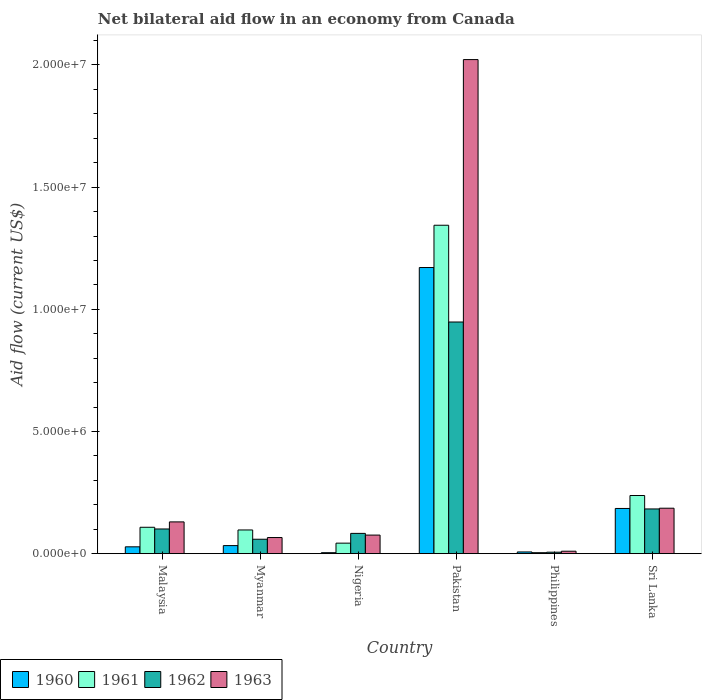How many different coloured bars are there?
Ensure brevity in your answer.  4. How many groups of bars are there?
Offer a very short reply. 6. Are the number of bars per tick equal to the number of legend labels?
Provide a succinct answer. Yes. What is the label of the 2nd group of bars from the left?
Ensure brevity in your answer.  Myanmar. In how many cases, is the number of bars for a given country not equal to the number of legend labels?
Your response must be concise. 0. What is the net bilateral aid flow in 1961 in Sri Lanka?
Offer a terse response. 2.38e+06. Across all countries, what is the maximum net bilateral aid flow in 1963?
Offer a terse response. 2.02e+07. In which country was the net bilateral aid flow in 1963 maximum?
Keep it short and to the point. Pakistan. What is the total net bilateral aid flow in 1960 in the graph?
Offer a very short reply. 1.43e+07. What is the difference between the net bilateral aid flow in 1963 in Myanmar and that in Sri Lanka?
Give a very brief answer. -1.20e+06. What is the difference between the net bilateral aid flow in 1962 in Pakistan and the net bilateral aid flow in 1963 in Sri Lanka?
Offer a terse response. 7.62e+06. What is the average net bilateral aid flow in 1960 per country?
Give a very brief answer. 2.38e+06. What is the ratio of the net bilateral aid flow in 1961 in Pakistan to that in Sri Lanka?
Make the answer very short. 5.65. What is the difference between the highest and the second highest net bilateral aid flow in 1961?
Offer a very short reply. 1.11e+07. What is the difference between the highest and the lowest net bilateral aid flow in 1963?
Give a very brief answer. 2.01e+07. Is the sum of the net bilateral aid flow in 1960 in Malaysia and Pakistan greater than the maximum net bilateral aid flow in 1961 across all countries?
Provide a succinct answer. No. Is it the case that in every country, the sum of the net bilateral aid flow in 1960 and net bilateral aid flow in 1961 is greater than the sum of net bilateral aid flow in 1963 and net bilateral aid flow in 1962?
Offer a very short reply. No. What does the 4th bar from the left in Nigeria represents?
Make the answer very short. 1963. Is it the case that in every country, the sum of the net bilateral aid flow in 1960 and net bilateral aid flow in 1962 is greater than the net bilateral aid flow in 1961?
Offer a terse response. No. Are all the bars in the graph horizontal?
Provide a short and direct response. No. How many countries are there in the graph?
Keep it short and to the point. 6. Does the graph contain grids?
Keep it short and to the point. No. Where does the legend appear in the graph?
Keep it short and to the point. Bottom left. How are the legend labels stacked?
Give a very brief answer. Horizontal. What is the title of the graph?
Your answer should be compact. Net bilateral aid flow in an economy from Canada. Does "2006" appear as one of the legend labels in the graph?
Give a very brief answer. No. What is the label or title of the Y-axis?
Offer a terse response. Aid flow (current US$). What is the Aid flow (current US$) in 1960 in Malaysia?
Keep it short and to the point. 2.80e+05. What is the Aid flow (current US$) in 1961 in Malaysia?
Make the answer very short. 1.08e+06. What is the Aid flow (current US$) in 1962 in Malaysia?
Ensure brevity in your answer.  1.01e+06. What is the Aid flow (current US$) in 1963 in Malaysia?
Your answer should be compact. 1.30e+06. What is the Aid flow (current US$) of 1961 in Myanmar?
Offer a terse response. 9.70e+05. What is the Aid flow (current US$) in 1962 in Myanmar?
Your answer should be compact. 5.90e+05. What is the Aid flow (current US$) of 1960 in Nigeria?
Ensure brevity in your answer.  4.00e+04. What is the Aid flow (current US$) in 1961 in Nigeria?
Ensure brevity in your answer.  4.30e+05. What is the Aid flow (current US$) in 1962 in Nigeria?
Your response must be concise. 8.30e+05. What is the Aid flow (current US$) of 1963 in Nigeria?
Offer a terse response. 7.60e+05. What is the Aid flow (current US$) of 1960 in Pakistan?
Make the answer very short. 1.17e+07. What is the Aid flow (current US$) of 1961 in Pakistan?
Your response must be concise. 1.34e+07. What is the Aid flow (current US$) of 1962 in Pakistan?
Offer a very short reply. 9.48e+06. What is the Aid flow (current US$) of 1963 in Pakistan?
Your answer should be compact. 2.02e+07. What is the Aid flow (current US$) in 1961 in Philippines?
Make the answer very short. 4.00e+04. What is the Aid flow (current US$) of 1960 in Sri Lanka?
Your answer should be very brief. 1.85e+06. What is the Aid flow (current US$) of 1961 in Sri Lanka?
Make the answer very short. 2.38e+06. What is the Aid flow (current US$) in 1962 in Sri Lanka?
Your answer should be compact. 1.83e+06. What is the Aid flow (current US$) in 1963 in Sri Lanka?
Your answer should be very brief. 1.86e+06. Across all countries, what is the maximum Aid flow (current US$) in 1960?
Provide a succinct answer. 1.17e+07. Across all countries, what is the maximum Aid flow (current US$) of 1961?
Give a very brief answer. 1.34e+07. Across all countries, what is the maximum Aid flow (current US$) in 1962?
Offer a terse response. 9.48e+06. Across all countries, what is the maximum Aid flow (current US$) in 1963?
Give a very brief answer. 2.02e+07. Across all countries, what is the minimum Aid flow (current US$) in 1961?
Ensure brevity in your answer.  4.00e+04. Across all countries, what is the minimum Aid flow (current US$) in 1962?
Your response must be concise. 6.00e+04. Across all countries, what is the minimum Aid flow (current US$) in 1963?
Make the answer very short. 1.00e+05. What is the total Aid flow (current US$) of 1960 in the graph?
Provide a short and direct response. 1.43e+07. What is the total Aid flow (current US$) of 1961 in the graph?
Keep it short and to the point. 1.83e+07. What is the total Aid flow (current US$) in 1962 in the graph?
Keep it short and to the point. 1.38e+07. What is the total Aid flow (current US$) of 1963 in the graph?
Provide a short and direct response. 2.49e+07. What is the difference between the Aid flow (current US$) of 1960 in Malaysia and that in Myanmar?
Ensure brevity in your answer.  -5.00e+04. What is the difference between the Aid flow (current US$) of 1961 in Malaysia and that in Myanmar?
Your answer should be very brief. 1.10e+05. What is the difference between the Aid flow (current US$) in 1962 in Malaysia and that in Myanmar?
Ensure brevity in your answer.  4.20e+05. What is the difference between the Aid flow (current US$) of 1963 in Malaysia and that in Myanmar?
Give a very brief answer. 6.40e+05. What is the difference between the Aid flow (current US$) of 1960 in Malaysia and that in Nigeria?
Your answer should be compact. 2.40e+05. What is the difference between the Aid flow (current US$) of 1961 in Malaysia and that in Nigeria?
Ensure brevity in your answer.  6.50e+05. What is the difference between the Aid flow (current US$) in 1963 in Malaysia and that in Nigeria?
Provide a succinct answer. 5.40e+05. What is the difference between the Aid flow (current US$) of 1960 in Malaysia and that in Pakistan?
Ensure brevity in your answer.  -1.14e+07. What is the difference between the Aid flow (current US$) in 1961 in Malaysia and that in Pakistan?
Your response must be concise. -1.24e+07. What is the difference between the Aid flow (current US$) in 1962 in Malaysia and that in Pakistan?
Provide a succinct answer. -8.47e+06. What is the difference between the Aid flow (current US$) of 1963 in Malaysia and that in Pakistan?
Ensure brevity in your answer.  -1.89e+07. What is the difference between the Aid flow (current US$) in 1960 in Malaysia and that in Philippines?
Ensure brevity in your answer.  2.10e+05. What is the difference between the Aid flow (current US$) of 1961 in Malaysia and that in Philippines?
Your answer should be very brief. 1.04e+06. What is the difference between the Aid flow (current US$) of 1962 in Malaysia and that in Philippines?
Ensure brevity in your answer.  9.50e+05. What is the difference between the Aid flow (current US$) of 1963 in Malaysia and that in Philippines?
Keep it short and to the point. 1.20e+06. What is the difference between the Aid flow (current US$) in 1960 in Malaysia and that in Sri Lanka?
Ensure brevity in your answer.  -1.57e+06. What is the difference between the Aid flow (current US$) of 1961 in Malaysia and that in Sri Lanka?
Provide a short and direct response. -1.30e+06. What is the difference between the Aid flow (current US$) of 1962 in Malaysia and that in Sri Lanka?
Make the answer very short. -8.20e+05. What is the difference between the Aid flow (current US$) in 1963 in Malaysia and that in Sri Lanka?
Your answer should be compact. -5.60e+05. What is the difference between the Aid flow (current US$) in 1961 in Myanmar and that in Nigeria?
Ensure brevity in your answer.  5.40e+05. What is the difference between the Aid flow (current US$) in 1962 in Myanmar and that in Nigeria?
Offer a terse response. -2.40e+05. What is the difference between the Aid flow (current US$) of 1960 in Myanmar and that in Pakistan?
Provide a short and direct response. -1.14e+07. What is the difference between the Aid flow (current US$) of 1961 in Myanmar and that in Pakistan?
Offer a terse response. -1.25e+07. What is the difference between the Aid flow (current US$) in 1962 in Myanmar and that in Pakistan?
Keep it short and to the point. -8.89e+06. What is the difference between the Aid flow (current US$) in 1963 in Myanmar and that in Pakistan?
Your answer should be compact. -1.96e+07. What is the difference between the Aid flow (current US$) of 1960 in Myanmar and that in Philippines?
Ensure brevity in your answer.  2.60e+05. What is the difference between the Aid flow (current US$) in 1961 in Myanmar and that in Philippines?
Provide a short and direct response. 9.30e+05. What is the difference between the Aid flow (current US$) of 1962 in Myanmar and that in Philippines?
Keep it short and to the point. 5.30e+05. What is the difference between the Aid flow (current US$) in 1963 in Myanmar and that in Philippines?
Offer a terse response. 5.60e+05. What is the difference between the Aid flow (current US$) in 1960 in Myanmar and that in Sri Lanka?
Offer a terse response. -1.52e+06. What is the difference between the Aid flow (current US$) in 1961 in Myanmar and that in Sri Lanka?
Your answer should be compact. -1.41e+06. What is the difference between the Aid flow (current US$) in 1962 in Myanmar and that in Sri Lanka?
Provide a succinct answer. -1.24e+06. What is the difference between the Aid flow (current US$) in 1963 in Myanmar and that in Sri Lanka?
Ensure brevity in your answer.  -1.20e+06. What is the difference between the Aid flow (current US$) of 1960 in Nigeria and that in Pakistan?
Provide a short and direct response. -1.17e+07. What is the difference between the Aid flow (current US$) of 1961 in Nigeria and that in Pakistan?
Your answer should be very brief. -1.30e+07. What is the difference between the Aid flow (current US$) in 1962 in Nigeria and that in Pakistan?
Ensure brevity in your answer.  -8.65e+06. What is the difference between the Aid flow (current US$) in 1963 in Nigeria and that in Pakistan?
Provide a succinct answer. -1.95e+07. What is the difference between the Aid flow (current US$) in 1960 in Nigeria and that in Philippines?
Make the answer very short. -3.00e+04. What is the difference between the Aid flow (current US$) in 1962 in Nigeria and that in Philippines?
Give a very brief answer. 7.70e+05. What is the difference between the Aid flow (current US$) of 1960 in Nigeria and that in Sri Lanka?
Keep it short and to the point. -1.81e+06. What is the difference between the Aid flow (current US$) in 1961 in Nigeria and that in Sri Lanka?
Provide a short and direct response. -1.95e+06. What is the difference between the Aid flow (current US$) in 1962 in Nigeria and that in Sri Lanka?
Ensure brevity in your answer.  -1.00e+06. What is the difference between the Aid flow (current US$) in 1963 in Nigeria and that in Sri Lanka?
Offer a terse response. -1.10e+06. What is the difference between the Aid flow (current US$) of 1960 in Pakistan and that in Philippines?
Provide a short and direct response. 1.16e+07. What is the difference between the Aid flow (current US$) in 1961 in Pakistan and that in Philippines?
Your answer should be very brief. 1.34e+07. What is the difference between the Aid flow (current US$) of 1962 in Pakistan and that in Philippines?
Your answer should be compact. 9.42e+06. What is the difference between the Aid flow (current US$) of 1963 in Pakistan and that in Philippines?
Offer a terse response. 2.01e+07. What is the difference between the Aid flow (current US$) of 1960 in Pakistan and that in Sri Lanka?
Offer a terse response. 9.86e+06. What is the difference between the Aid flow (current US$) in 1961 in Pakistan and that in Sri Lanka?
Give a very brief answer. 1.11e+07. What is the difference between the Aid flow (current US$) in 1962 in Pakistan and that in Sri Lanka?
Your answer should be very brief. 7.65e+06. What is the difference between the Aid flow (current US$) in 1963 in Pakistan and that in Sri Lanka?
Offer a terse response. 1.84e+07. What is the difference between the Aid flow (current US$) of 1960 in Philippines and that in Sri Lanka?
Make the answer very short. -1.78e+06. What is the difference between the Aid flow (current US$) in 1961 in Philippines and that in Sri Lanka?
Offer a terse response. -2.34e+06. What is the difference between the Aid flow (current US$) of 1962 in Philippines and that in Sri Lanka?
Your answer should be very brief. -1.77e+06. What is the difference between the Aid flow (current US$) of 1963 in Philippines and that in Sri Lanka?
Keep it short and to the point. -1.76e+06. What is the difference between the Aid flow (current US$) in 1960 in Malaysia and the Aid flow (current US$) in 1961 in Myanmar?
Your response must be concise. -6.90e+05. What is the difference between the Aid flow (current US$) of 1960 in Malaysia and the Aid flow (current US$) of 1962 in Myanmar?
Your response must be concise. -3.10e+05. What is the difference between the Aid flow (current US$) in 1960 in Malaysia and the Aid flow (current US$) in 1963 in Myanmar?
Your response must be concise. -3.80e+05. What is the difference between the Aid flow (current US$) in 1960 in Malaysia and the Aid flow (current US$) in 1962 in Nigeria?
Ensure brevity in your answer.  -5.50e+05. What is the difference between the Aid flow (current US$) of 1960 in Malaysia and the Aid flow (current US$) of 1963 in Nigeria?
Keep it short and to the point. -4.80e+05. What is the difference between the Aid flow (current US$) of 1961 in Malaysia and the Aid flow (current US$) of 1962 in Nigeria?
Give a very brief answer. 2.50e+05. What is the difference between the Aid flow (current US$) of 1961 in Malaysia and the Aid flow (current US$) of 1963 in Nigeria?
Give a very brief answer. 3.20e+05. What is the difference between the Aid flow (current US$) of 1960 in Malaysia and the Aid flow (current US$) of 1961 in Pakistan?
Give a very brief answer. -1.32e+07. What is the difference between the Aid flow (current US$) of 1960 in Malaysia and the Aid flow (current US$) of 1962 in Pakistan?
Provide a short and direct response. -9.20e+06. What is the difference between the Aid flow (current US$) in 1960 in Malaysia and the Aid flow (current US$) in 1963 in Pakistan?
Offer a very short reply. -1.99e+07. What is the difference between the Aid flow (current US$) of 1961 in Malaysia and the Aid flow (current US$) of 1962 in Pakistan?
Offer a terse response. -8.40e+06. What is the difference between the Aid flow (current US$) in 1961 in Malaysia and the Aid flow (current US$) in 1963 in Pakistan?
Ensure brevity in your answer.  -1.91e+07. What is the difference between the Aid flow (current US$) in 1962 in Malaysia and the Aid flow (current US$) in 1963 in Pakistan?
Provide a short and direct response. -1.92e+07. What is the difference between the Aid flow (current US$) of 1961 in Malaysia and the Aid flow (current US$) of 1962 in Philippines?
Provide a short and direct response. 1.02e+06. What is the difference between the Aid flow (current US$) of 1961 in Malaysia and the Aid flow (current US$) of 1963 in Philippines?
Give a very brief answer. 9.80e+05. What is the difference between the Aid flow (current US$) of 1962 in Malaysia and the Aid flow (current US$) of 1963 in Philippines?
Your answer should be very brief. 9.10e+05. What is the difference between the Aid flow (current US$) in 1960 in Malaysia and the Aid flow (current US$) in 1961 in Sri Lanka?
Give a very brief answer. -2.10e+06. What is the difference between the Aid flow (current US$) of 1960 in Malaysia and the Aid flow (current US$) of 1962 in Sri Lanka?
Provide a short and direct response. -1.55e+06. What is the difference between the Aid flow (current US$) of 1960 in Malaysia and the Aid flow (current US$) of 1963 in Sri Lanka?
Provide a short and direct response. -1.58e+06. What is the difference between the Aid flow (current US$) in 1961 in Malaysia and the Aid flow (current US$) in 1962 in Sri Lanka?
Your answer should be very brief. -7.50e+05. What is the difference between the Aid flow (current US$) in 1961 in Malaysia and the Aid flow (current US$) in 1963 in Sri Lanka?
Your response must be concise. -7.80e+05. What is the difference between the Aid flow (current US$) of 1962 in Malaysia and the Aid flow (current US$) of 1963 in Sri Lanka?
Your answer should be very brief. -8.50e+05. What is the difference between the Aid flow (current US$) of 1960 in Myanmar and the Aid flow (current US$) of 1962 in Nigeria?
Provide a succinct answer. -5.00e+05. What is the difference between the Aid flow (current US$) in 1960 in Myanmar and the Aid flow (current US$) in 1963 in Nigeria?
Your response must be concise. -4.30e+05. What is the difference between the Aid flow (current US$) of 1961 in Myanmar and the Aid flow (current US$) of 1962 in Nigeria?
Provide a short and direct response. 1.40e+05. What is the difference between the Aid flow (current US$) of 1960 in Myanmar and the Aid flow (current US$) of 1961 in Pakistan?
Give a very brief answer. -1.31e+07. What is the difference between the Aid flow (current US$) in 1960 in Myanmar and the Aid flow (current US$) in 1962 in Pakistan?
Provide a short and direct response. -9.15e+06. What is the difference between the Aid flow (current US$) of 1960 in Myanmar and the Aid flow (current US$) of 1963 in Pakistan?
Offer a terse response. -1.99e+07. What is the difference between the Aid flow (current US$) of 1961 in Myanmar and the Aid flow (current US$) of 1962 in Pakistan?
Your answer should be very brief. -8.51e+06. What is the difference between the Aid flow (current US$) of 1961 in Myanmar and the Aid flow (current US$) of 1963 in Pakistan?
Your answer should be very brief. -1.92e+07. What is the difference between the Aid flow (current US$) of 1962 in Myanmar and the Aid flow (current US$) of 1963 in Pakistan?
Offer a terse response. -1.96e+07. What is the difference between the Aid flow (current US$) of 1960 in Myanmar and the Aid flow (current US$) of 1962 in Philippines?
Provide a succinct answer. 2.70e+05. What is the difference between the Aid flow (current US$) in 1961 in Myanmar and the Aid flow (current US$) in 1962 in Philippines?
Provide a short and direct response. 9.10e+05. What is the difference between the Aid flow (current US$) of 1961 in Myanmar and the Aid flow (current US$) of 1963 in Philippines?
Offer a very short reply. 8.70e+05. What is the difference between the Aid flow (current US$) of 1960 in Myanmar and the Aid flow (current US$) of 1961 in Sri Lanka?
Make the answer very short. -2.05e+06. What is the difference between the Aid flow (current US$) in 1960 in Myanmar and the Aid flow (current US$) in 1962 in Sri Lanka?
Your answer should be very brief. -1.50e+06. What is the difference between the Aid flow (current US$) of 1960 in Myanmar and the Aid flow (current US$) of 1963 in Sri Lanka?
Keep it short and to the point. -1.53e+06. What is the difference between the Aid flow (current US$) in 1961 in Myanmar and the Aid flow (current US$) in 1962 in Sri Lanka?
Keep it short and to the point. -8.60e+05. What is the difference between the Aid flow (current US$) in 1961 in Myanmar and the Aid flow (current US$) in 1963 in Sri Lanka?
Make the answer very short. -8.90e+05. What is the difference between the Aid flow (current US$) in 1962 in Myanmar and the Aid flow (current US$) in 1963 in Sri Lanka?
Offer a terse response. -1.27e+06. What is the difference between the Aid flow (current US$) in 1960 in Nigeria and the Aid flow (current US$) in 1961 in Pakistan?
Provide a succinct answer. -1.34e+07. What is the difference between the Aid flow (current US$) of 1960 in Nigeria and the Aid flow (current US$) of 1962 in Pakistan?
Make the answer very short. -9.44e+06. What is the difference between the Aid flow (current US$) of 1960 in Nigeria and the Aid flow (current US$) of 1963 in Pakistan?
Keep it short and to the point. -2.02e+07. What is the difference between the Aid flow (current US$) in 1961 in Nigeria and the Aid flow (current US$) in 1962 in Pakistan?
Your answer should be compact. -9.05e+06. What is the difference between the Aid flow (current US$) of 1961 in Nigeria and the Aid flow (current US$) of 1963 in Pakistan?
Your answer should be very brief. -1.98e+07. What is the difference between the Aid flow (current US$) of 1962 in Nigeria and the Aid flow (current US$) of 1963 in Pakistan?
Give a very brief answer. -1.94e+07. What is the difference between the Aid flow (current US$) of 1960 in Nigeria and the Aid flow (current US$) of 1961 in Philippines?
Provide a succinct answer. 0. What is the difference between the Aid flow (current US$) in 1960 in Nigeria and the Aid flow (current US$) in 1962 in Philippines?
Offer a terse response. -2.00e+04. What is the difference between the Aid flow (current US$) of 1960 in Nigeria and the Aid flow (current US$) of 1963 in Philippines?
Your answer should be compact. -6.00e+04. What is the difference between the Aid flow (current US$) of 1961 in Nigeria and the Aid flow (current US$) of 1963 in Philippines?
Give a very brief answer. 3.30e+05. What is the difference between the Aid flow (current US$) in 1962 in Nigeria and the Aid flow (current US$) in 1963 in Philippines?
Offer a terse response. 7.30e+05. What is the difference between the Aid flow (current US$) of 1960 in Nigeria and the Aid flow (current US$) of 1961 in Sri Lanka?
Ensure brevity in your answer.  -2.34e+06. What is the difference between the Aid flow (current US$) in 1960 in Nigeria and the Aid flow (current US$) in 1962 in Sri Lanka?
Your answer should be very brief. -1.79e+06. What is the difference between the Aid flow (current US$) of 1960 in Nigeria and the Aid flow (current US$) of 1963 in Sri Lanka?
Offer a very short reply. -1.82e+06. What is the difference between the Aid flow (current US$) of 1961 in Nigeria and the Aid flow (current US$) of 1962 in Sri Lanka?
Offer a terse response. -1.40e+06. What is the difference between the Aid flow (current US$) in 1961 in Nigeria and the Aid flow (current US$) in 1963 in Sri Lanka?
Give a very brief answer. -1.43e+06. What is the difference between the Aid flow (current US$) of 1962 in Nigeria and the Aid flow (current US$) of 1963 in Sri Lanka?
Your answer should be compact. -1.03e+06. What is the difference between the Aid flow (current US$) of 1960 in Pakistan and the Aid flow (current US$) of 1961 in Philippines?
Provide a short and direct response. 1.17e+07. What is the difference between the Aid flow (current US$) of 1960 in Pakistan and the Aid flow (current US$) of 1962 in Philippines?
Make the answer very short. 1.16e+07. What is the difference between the Aid flow (current US$) in 1960 in Pakistan and the Aid flow (current US$) in 1963 in Philippines?
Your response must be concise. 1.16e+07. What is the difference between the Aid flow (current US$) in 1961 in Pakistan and the Aid flow (current US$) in 1962 in Philippines?
Keep it short and to the point. 1.34e+07. What is the difference between the Aid flow (current US$) in 1961 in Pakistan and the Aid flow (current US$) in 1963 in Philippines?
Provide a succinct answer. 1.33e+07. What is the difference between the Aid flow (current US$) of 1962 in Pakistan and the Aid flow (current US$) of 1963 in Philippines?
Give a very brief answer. 9.38e+06. What is the difference between the Aid flow (current US$) in 1960 in Pakistan and the Aid flow (current US$) in 1961 in Sri Lanka?
Give a very brief answer. 9.33e+06. What is the difference between the Aid flow (current US$) in 1960 in Pakistan and the Aid flow (current US$) in 1962 in Sri Lanka?
Make the answer very short. 9.88e+06. What is the difference between the Aid flow (current US$) of 1960 in Pakistan and the Aid flow (current US$) of 1963 in Sri Lanka?
Make the answer very short. 9.85e+06. What is the difference between the Aid flow (current US$) of 1961 in Pakistan and the Aid flow (current US$) of 1962 in Sri Lanka?
Make the answer very short. 1.16e+07. What is the difference between the Aid flow (current US$) in 1961 in Pakistan and the Aid flow (current US$) in 1963 in Sri Lanka?
Give a very brief answer. 1.16e+07. What is the difference between the Aid flow (current US$) in 1962 in Pakistan and the Aid flow (current US$) in 1963 in Sri Lanka?
Your answer should be compact. 7.62e+06. What is the difference between the Aid flow (current US$) of 1960 in Philippines and the Aid flow (current US$) of 1961 in Sri Lanka?
Offer a terse response. -2.31e+06. What is the difference between the Aid flow (current US$) in 1960 in Philippines and the Aid flow (current US$) in 1962 in Sri Lanka?
Offer a very short reply. -1.76e+06. What is the difference between the Aid flow (current US$) of 1960 in Philippines and the Aid flow (current US$) of 1963 in Sri Lanka?
Make the answer very short. -1.79e+06. What is the difference between the Aid flow (current US$) of 1961 in Philippines and the Aid flow (current US$) of 1962 in Sri Lanka?
Your answer should be compact. -1.79e+06. What is the difference between the Aid flow (current US$) in 1961 in Philippines and the Aid flow (current US$) in 1963 in Sri Lanka?
Your answer should be compact. -1.82e+06. What is the difference between the Aid flow (current US$) of 1962 in Philippines and the Aid flow (current US$) of 1963 in Sri Lanka?
Offer a terse response. -1.80e+06. What is the average Aid flow (current US$) of 1960 per country?
Offer a terse response. 2.38e+06. What is the average Aid flow (current US$) of 1961 per country?
Ensure brevity in your answer.  3.06e+06. What is the average Aid flow (current US$) of 1962 per country?
Make the answer very short. 2.30e+06. What is the average Aid flow (current US$) of 1963 per country?
Provide a short and direct response. 4.15e+06. What is the difference between the Aid flow (current US$) in 1960 and Aid flow (current US$) in 1961 in Malaysia?
Your answer should be compact. -8.00e+05. What is the difference between the Aid flow (current US$) of 1960 and Aid flow (current US$) of 1962 in Malaysia?
Your response must be concise. -7.30e+05. What is the difference between the Aid flow (current US$) of 1960 and Aid flow (current US$) of 1963 in Malaysia?
Offer a terse response. -1.02e+06. What is the difference between the Aid flow (current US$) of 1961 and Aid flow (current US$) of 1962 in Malaysia?
Provide a short and direct response. 7.00e+04. What is the difference between the Aid flow (current US$) in 1961 and Aid flow (current US$) in 1963 in Malaysia?
Your answer should be very brief. -2.20e+05. What is the difference between the Aid flow (current US$) in 1962 and Aid flow (current US$) in 1963 in Malaysia?
Make the answer very short. -2.90e+05. What is the difference between the Aid flow (current US$) in 1960 and Aid flow (current US$) in 1961 in Myanmar?
Give a very brief answer. -6.40e+05. What is the difference between the Aid flow (current US$) in 1960 and Aid flow (current US$) in 1962 in Myanmar?
Give a very brief answer. -2.60e+05. What is the difference between the Aid flow (current US$) of 1960 and Aid flow (current US$) of 1963 in Myanmar?
Your answer should be very brief. -3.30e+05. What is the difference between the Aid flow (current US$) of 1961 and Aid flow (current US$) of 1962 in Myanmar?
Your response must be concise. 3.80e+05. What is the difference between the Aid flow (current US$) of 1962 and Aid flow (current US$) of 1963 in Myanmar?
Offer a very short reply. -7.00e+04. What is the difference between the Aid flow (current US$) in 1960 and Aid flow (current US$) in 1961 in Nigeria?
Give a very brief answer. -3.90e+05. What is the difference between the Aid flow (current US$) in 1960 and Aid flow (current US$) in 1962 in Nigeria?
Make the answer very short. -7.90e+05. What is the difference between the Aid flow (current US$) of 1960 and Aid flow (current US$) of 1963 in Nigeria?
Keep it short and to the point. -7.20e+05. What is the difference between the Aid flow (current US$) in 1961 and Aid flow (current US$) in 1962 in Nigeria?
Provide a succinct answer. -4.00e+05. What is the difference between the Aid flow (current US$) of 1961 and Aid flow (current US$) of 1963 in Nigeria?
Your response must be concise. -3.30e+05. What is the difference between the Aid flow (current US$) of 1960 and Aid flow (current US$) of 1961 in Pakistan?
Ensure brevity in your answer.  -1.73e+06. What is the difference between the Aid flow (current US$) in 1960 and Aid flow (current US$) in 1962 in Pakistan?
Provide a short and direct response. 2.23e+06. What is the difference between the Aid flow (current US$) of 1960 and Aid flow (current US$) of 1963 in Pakistan?
Give a very brief answer. -8.51e+06. What is the difference between the Aid flow (current US$) in 1961 and Aid flow (current US$) in 1962 in Pakistan?
Your answer should be compact. 3.96e+06. What is the difference between the Aid flow (current US$) of 1961 and Aid flow (current US$) of 1963 in Pakistan?
Provide a succinct answer. -6.78e+06. What is the difference between the Aid flow (current US$) of 1962 and Aid flow (current US$) of 1963 in Pakistan?
Ensure brevity in your answer.  -1.07e+07. What is the difference between the Aid flow (current US$) in 1960 and Aid flow (current US$) in 1961 in Philippines?
Make the answer very short. 3.00e+04. What is the difference between the Aid flow (current US$) in 1960 and Aid flow (current US$) in 1962 in Philippines?
Provide a short and direct response. 10000. What is the difference between the Aid flow (current US$) of 1962 and Aid flow (current US$) of 1963 in Philippines?
Make the answer very short. -4.00e+04. What is the difference between the Aid flow (current US$) of 1960 and Aid flow (current US$) of 1961 in Sri Lanka?
Provide a short and direct response. -5.30e+05. What is the difference between the Aid flow (current US$) in 1960 and Aid flow (current US$) in 1963 in Sri Lanka?
Offer a very short reply. -10000. What is the difference between the Aid flow (current US$) of 1961 and Aid flow (current US$) of 1962 in Sri Lanka?
Provide a short and direct response. 5.50e+05. What is the difference between the Aid flow (current US$) in 1961 and Aid flow (current US$) in 1963 in Sri Lanka?
Ensure brevity in your answer.  5.20e+05. What is the ratio of the Aid flow (current US$) in 1960 in Malaysia to that in Myanmar?
Offer a very short reply. 0.85. What is the ratio of the Aid flow (current US$) in 1961 in Malaysia to that in Myanmar?
Provide a succinct answer. 1.11. What is the ratio of the Aid flow (current US$) of 1962 in Malaysia to that in Myanmar?
Your answer should be compact. 1.71. What is the ratio of the Aid flow (current US$) in 1963 in Malaysia to that in Myanmar?
Give a very brief answer. 1.97. What is the ratio of the Aid flow (current US$) in 1960 in Malaysia to that in Nigeria?
Keep it short and to the point. 7. What is the ratio of the Aid flow (current US$) of 1961 in Malaysia to that in Nigeria?
Give a very brief answer. 2.51. What is the ratio of the Aid flow (current US$) in 1962 in Malaysia to that in Nigeria?
Keep it short and to the point. 1.22. What is the ratio of the Aid flow (current US$) of 1963 in Malaysia to that in Nigeria?
Your answer should be very brief. 1.71. What is the ratio of the Aid flow (current US$) of 1960 in Malaysia to that in Pakistan?
Offer a terse response. 0.02. What is the ratio of the Aid flow (current US$) of 1961 in Malaysia to that in Pakistan?
Provide a short and direct response. 0.08. What is the ratio of the Aid flow (current US$) in 1962 in Malaysia to that in Pakistan?
Provide a short and direct response. 0.11. What is the ratio of the Aid flow (current US$) of 1963 in Malaysia to that in Pakistan?
Your response must be concise. 0.06. What is the ratio of the Aid flow (current US$) in 1960 in Malaysia to that in Philippines?
Offer a very short reply. 4. What is the ratio of the Aid flow (current US$) in 1962 in Malaysia to that in Philippines?
Provide a succinct answer. 16.83. What is the ratio of the Aid flow (current US$) in 1960 in Malaysia to that in Sri Lanka?
Provide a short and direct response. 0.15. What is the ratio of the Aid flow (current US$) of 1961 in Malaysia to that in Sri Lanka?
Your answer should be compact. 0.45. What is the ratio of the Aid flow (current US$) of 1962 in Malaysia to that in Sri Lanka?
Keep it short and to the point. 0.55. What is the ratio of the Aid flow (current US$) of 1963 in Malaysia to that in Sri Lanka?
Keep it short and to the point. 0.7. What is the ratio of the Aid flow (current US$) of 1960 in Myanmar to that in Nigeria?
Your answer should be compact. 8.25. What is the ratio of the Aid flow (current US$) of 1961 in Myanmar to that in Nigeria?
Make the answer very short. 2.26. What is the ratio of the Aid flow (current US$) of 1962 in Myanmar to that in Nigeria?
Give a very brief answer. 0.71. What is the ratio of the Aid flow (current US$) of 1963 in Myanmar to that in Nigeria?
Provide a succinct answer. 0.87. What is the ratio of the Aid flow (current US$) of 1960 in Myanmar to that in Pakistan?
Provide a succinct answer. 0.03. What is the ratio of the Aid flow (current US$) in 1961 in Myanmar to that in Pakistan?
Provide a succinct answer. 0.07. What is the ratio of the Aid flow (current US$) of 1962 in Myanmar to that in Pakistan?
Your answer should be compact. 0.06. What is the ratio of the Aid flow (current US$) of 1963 in Myanmar to that in Pakistan?
Offer a terse response. 0.03. What is the ratio of the Aid flow (current US$) in 1960 in Myanmar to that in Philippines?
Offer a terse response. 4.71. What is the ratio of the Aid flow (current US$) in 1961 in Myanmar to that in Philippines?
Provide a short and direct response. 24.25. What is the ratio of the Aid flow (current US$) of 1962 in Myanmar to that in Philippines?
Provide a short and direct response. 9.83. What is the ratio of the Aid flow (current US$) in 1960 in Myanmar to that in Sri Lanka?
Provide a succinct answer. 0.18. What is the ratio of the Aid flow (current US$) of 1961 in Myanmar to that in Sri Lanka?
Offer a terse response. 0.41. What is the ratio of the Aid flow (current US$) of 1962 in Myanmar to that in Sri Lanka?
Make the answer very short. 0.32. What is the ratio of the Aid flow (current US$) in 1963 in Myanmar to that in Sri Lanka?
Offer a very short reply. 0.35. What is the ratio of the Aid flow (current US$) in 1960 in Nigeria to that in Pakistan?
Offer a very short reply. 0. What is the ratio of the Aid flow (current US$) in 1961 in Nigeria to that in Pakistan?
Make the answer very short. 0.03. What is the ratio of the Aid flow (current US$) in 1962 in Nigeria to that in Pakistan?
Offer a terse response. 0.09. What is the ratio of the Aid flow (current US$) in 1963 in Nigeria to that in Pakistan?
Give a very brief answer. 0.04. What is the ratio of the Aid flow (current US$) of 1960 in Nigeria to that in Philippines?
Give a very brief answer. 0.57. What is the ratio of the Aid flow (current US$) of 1961 in Nigeria to that in Philippines?
Provide a short and direct response. 10.75. What is the ratio of the Aid flow (current US$) in 1962 in Nigeria to that in Philippines?
Provide a succinct answer. 13.83. What is the ratio of the Aid flow (current US$) in 1963 in Nigeria to that in Philippines?
Your answer should be very brief. 7.6. What is the ratio of the Aid flow (current US$) of 1960 in Nigeria to that in Sri Lanka?
Your answer should be compact. 0.02. What is the ratio of the Aid flow (current US$) of 1961 in Nigeria to that in Sri Lanka?
Keep it short and to the point. 0.18. What is the ratio of the Aid flow (current US$) in 1962 in Nigeria to that in Sri Lanka?
Offer a very short reply. 0.45. What is the ratio of the Aid flow (current US$) of 1963 in Nigeria to that in Sri Lanka?
Offer a very short reply. 0.41. What is the ratio of the Aid flow (current US$) of 1960 in Pakistan to that in Philippines?
Keep it short and to the point. 167.29. What is the ratio of the Aid flow (current US$) of 1961 in Pakistan to that in Philippines?
Provide a short and direct response. 336. What is the ratio of the Aid flow (current US$) of 1962 in Pakistan to that in Philippines?
Offer a very short reply. 158. What is the ratio of the Aid flow (current US$) in 1963 in Pakistan to that in Philippines?
Offer a terse response. 202.2. What is the ratio of the Aid flow (current US$) in 1960 in Pakistan to that in Sri Lanka?
Ensure brevity in your answer.  6.33. What is the ratio of the Aid flow (current US$) of 1961 in Pakistan to that in Sri Lanka?
Give a very brief answer. 5.65. What is the ratio of the Aid flow (current US$) of 1962 in Pakistan to that in Sri Lanka?
Ensure brevity in your answer.  5.18. What is the ratio of the Aid flow (current US$) in 1963 in Pakistan to that in Sri Lanka?
Keep it short and to the point. 10.87. What is the ratio of the Aid flow (current US$) in 1960 in Philippines to that in Sri Lanka?
Your response must be concise. 0.04. What is the ratio of the Aid flow (current US$) of 1961 in Philippines to that in Sri Lanka?
Offer a terse response. 0.02. What is the ratio of the Aid flow (current US$) of 1962 in Philippines to that in Sri Lanka?
Make the answer very short. 0.03. What is the ratio of the Aid flow (current US$) of 1963 in Philippines to that in Sri Lanka?
Provide a succinct answer. 0.05. What is the difference between the highest and the second highest Aid flow (current US$) of 1960?
Your answer should be very brief. 9.86e+06. What is the difference between the highest and the second highest Aid flow (current US$) of 1961?
Provide a short and direct response. 1.11e+07. What is the difference between the highest and the second highest Aid flow (current US$) of 1962?
Make the answer very short. 7.65e+06. What is the difference between the highest and the second highest Aid flow (current US$) in 1963?
Offer a very short reply. 1.84e+07. What is the difference between the highest and the lowest Aid flow (current US$) of 1960?
Offer a terse response. 1.17e+07. What is the difference between the highest and the lowest Aid flow (current US$) in 1961?
Offer a very short reply. 1.34e+07. What is the difference between the highest and the lowest Aid flow (current US$) in 1962?
Your response must be concise. 9.42e+06. What is the difference between the highest and the lowest Aid flow (current US$) in 1963?
Keep it short and to the point. 2.01e+07. 